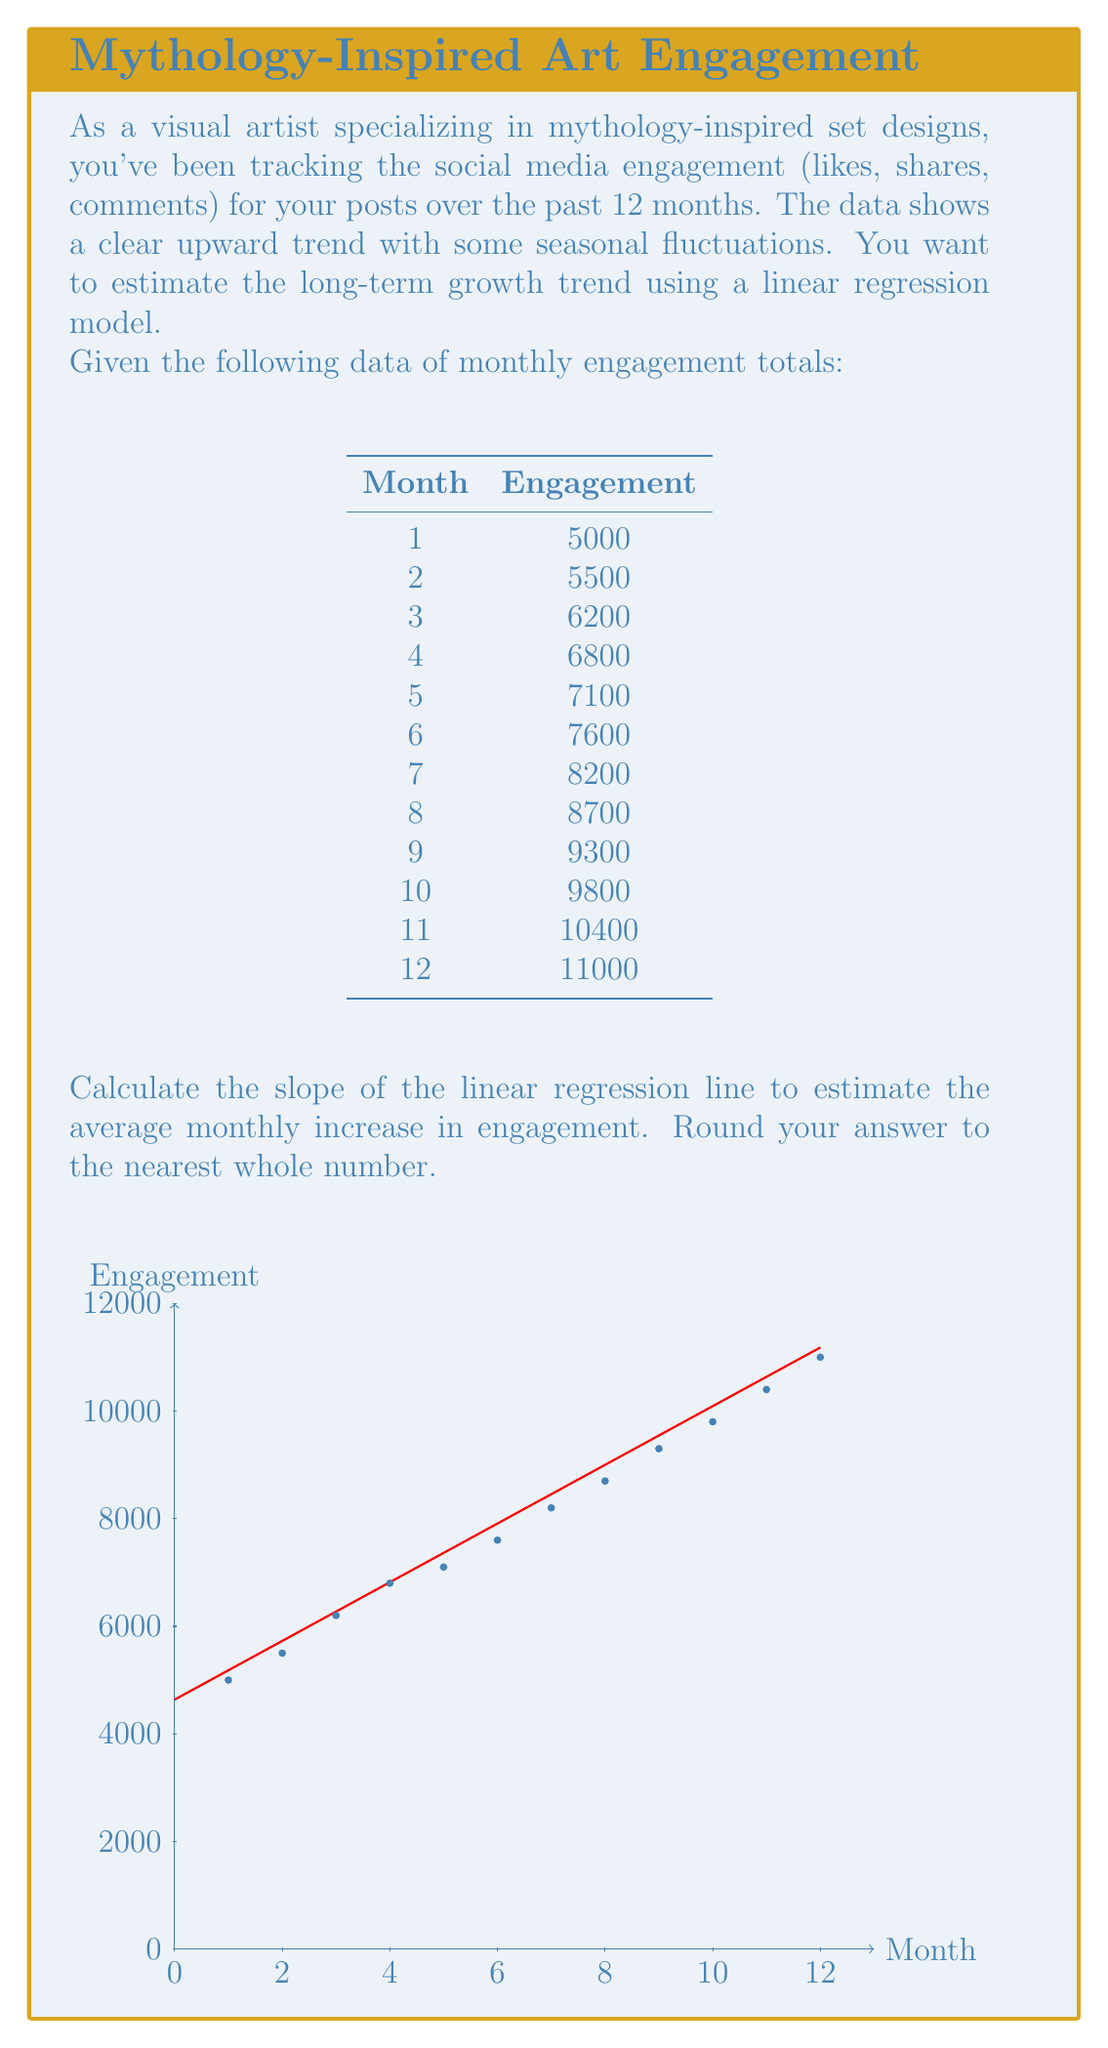Give your solution to this math problem. To calculate the slope of the linear regression line, we'll use the formula:

$$ m = \frac{n\sum xy - \sum x \sum y}{n\sum x^2 - (\sum x)^2} $$

Where:
$m$ is the slope
$n$ is the number of data points
$x$ represents the months
$y$ represents the engagement values

Step 1: Calculate the necessary sums:
$n = 12$
$\sum x = 1 + 2 + 3 + ... + 12 = 78$
$\sum y = 5000 + 5500 + 6200 + ... + 11000 = 95600$
$\sum xy = 1(5000) + 2(5500) + 3(6200) + ... + 12(11000) = 770500$
$\sum x^2 = 1^2 + 2^2 + 3^2 + ... + 12^2 = 650$

Step 2: Substitute these values into the slope formula:

$$ m = \frac{12(770500) - 78(95600)}{12(650) - 78^2} $$

Step 3: Simplify:

$$ m = \frac{9246000 - 7456800}{7800 - 6084} $$
$$ m = \frac{1789200}{1716} $$
$$ m \approx 545.45 $$

Step 4: Round to the nearest whole number:

$m \approx 545$

This means that, on average, the social media engagement increases by approximately 545 units per month.
Answer: 545 